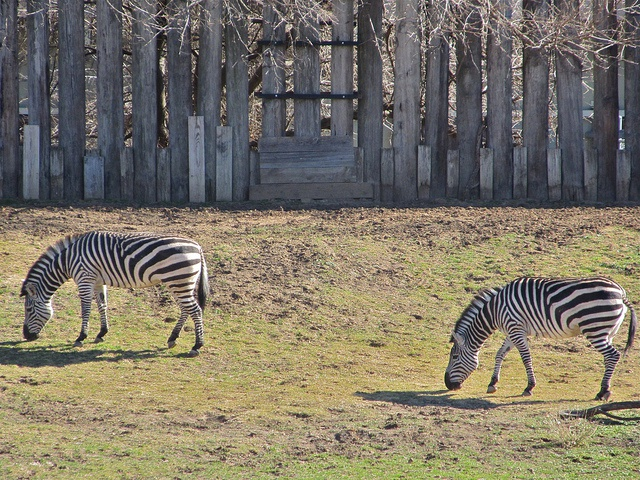Describe the objects in this image and their specific colors. I can see zebra in black, darkgray, gray, and tan tones and zebra in black, darkgray, gray, and tan tones in this image. 